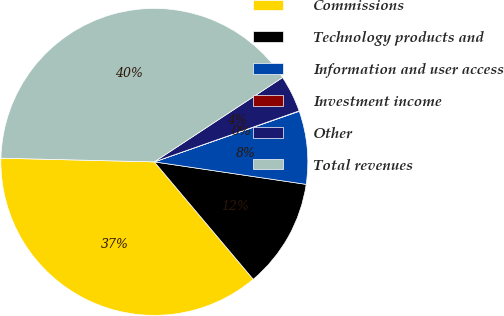<chart> <loc_0><loc_0><loc_500><loc_500><pie_chart><fcel>Commissions<fcel>Technology products and<fcel>Information and user access<fcel>Investment income<fcel>Other<fcel>Total revenues<nl><fcel>36.53%<fcel>11.52%<fcel>7.69%<fcel>0.04%<fcel>3.87%<fcel>40.36%<nl></chart> 